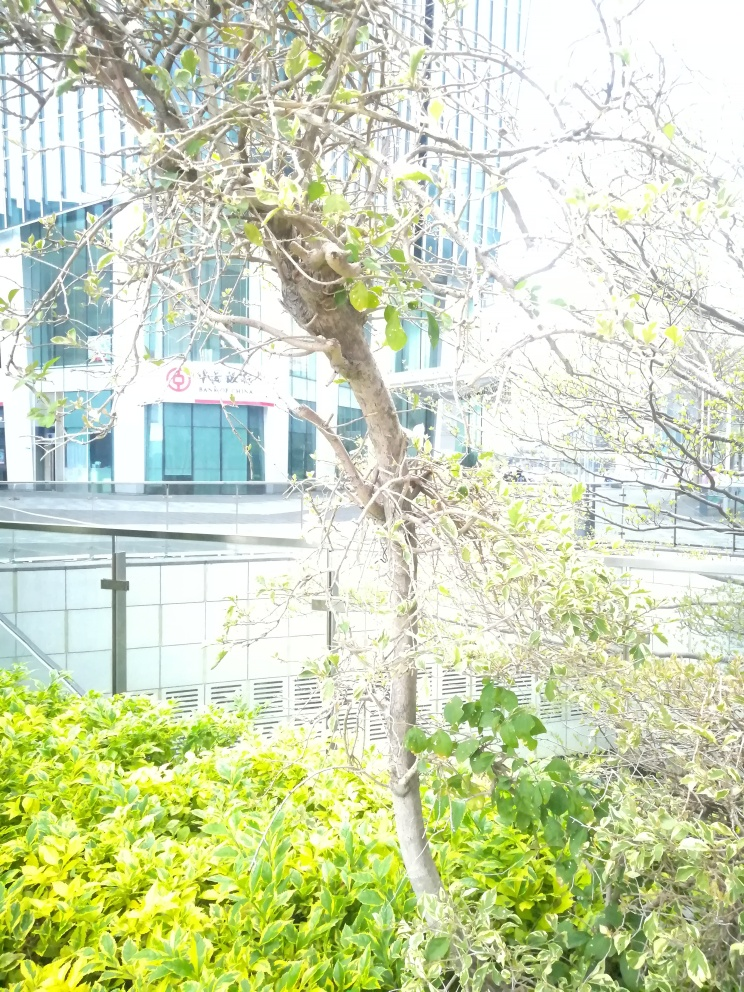Are the darker parts of the buildings underexposed? The darker parts of the buildings do not appear to be underexposed. Upon careful examination, the overall brightness levels seem balanced; however, the photograph has a high contrast between shadows and well-lit areas, which may cause some areas to appear darker in comparison to the brightly lit sections. 